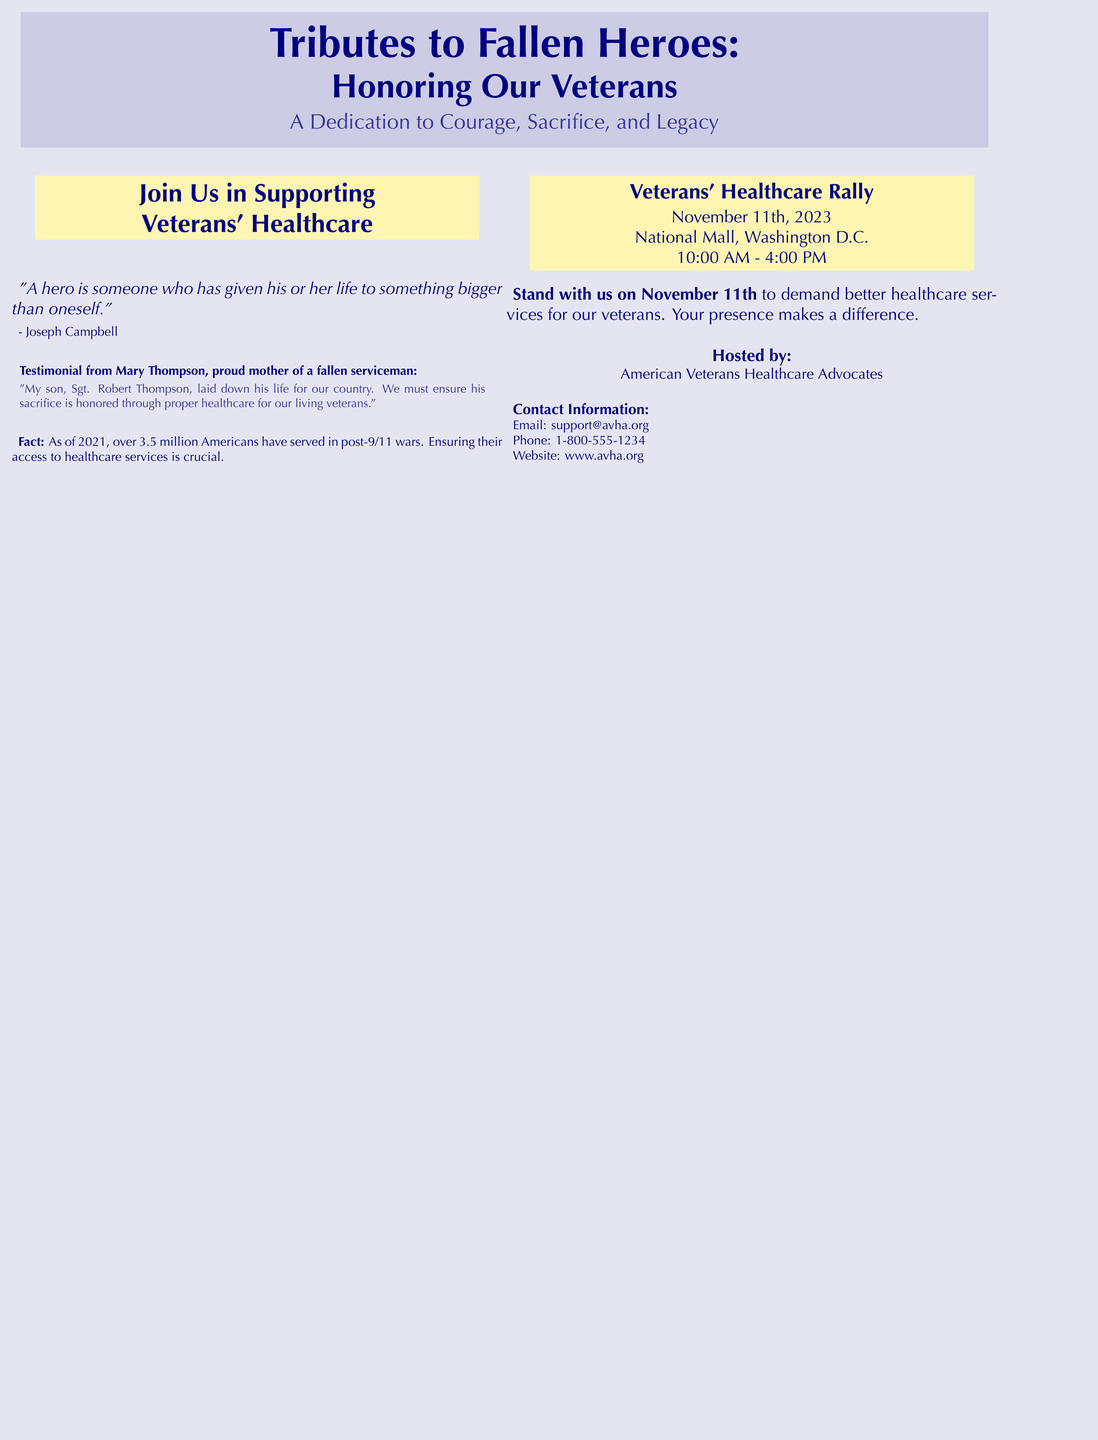What is the event date for the Veterans' Healthcare Rally? The event date is specified in the document as November 11th, 2023.
Answer: November 11th, 2023 Who is the testimonial from in the poster? The testimonial is from Mary Thompson, who is identified as the proud mother of a fallen serviceman.
Answer: Mary Thompson What time does the rally start? The start time for the rally is given in the document as 10:00 AM.
Answer: 10:00 AM What organization is hosting the event? The poster states that the event is hosted by the American Veterans Healthcare Advocates.
Answer: American Veterans Healthcare Advocates How many Americans served in post-9/11 wars as of 2021? The document mentions that over 3.5 million Americans have served in post-9/11 wars.
Answer: over 3.5 million What is the main purpose of the rally? The document states that the purpose is to demand better healthcare services for veterans.
Answer: Demand better healthcare services for veterans What is the color scheme used in the poster? The poster prominently features navy blue and golden yellow colors.
Answer: Navy blue and golden yellow What notable quote is included in the poster? The quote provided by Joseph Campbell is about the nature of a hero and their sacrifice.
Answer: "A hero is someone who has given his or her life to something bigger than oneself." 